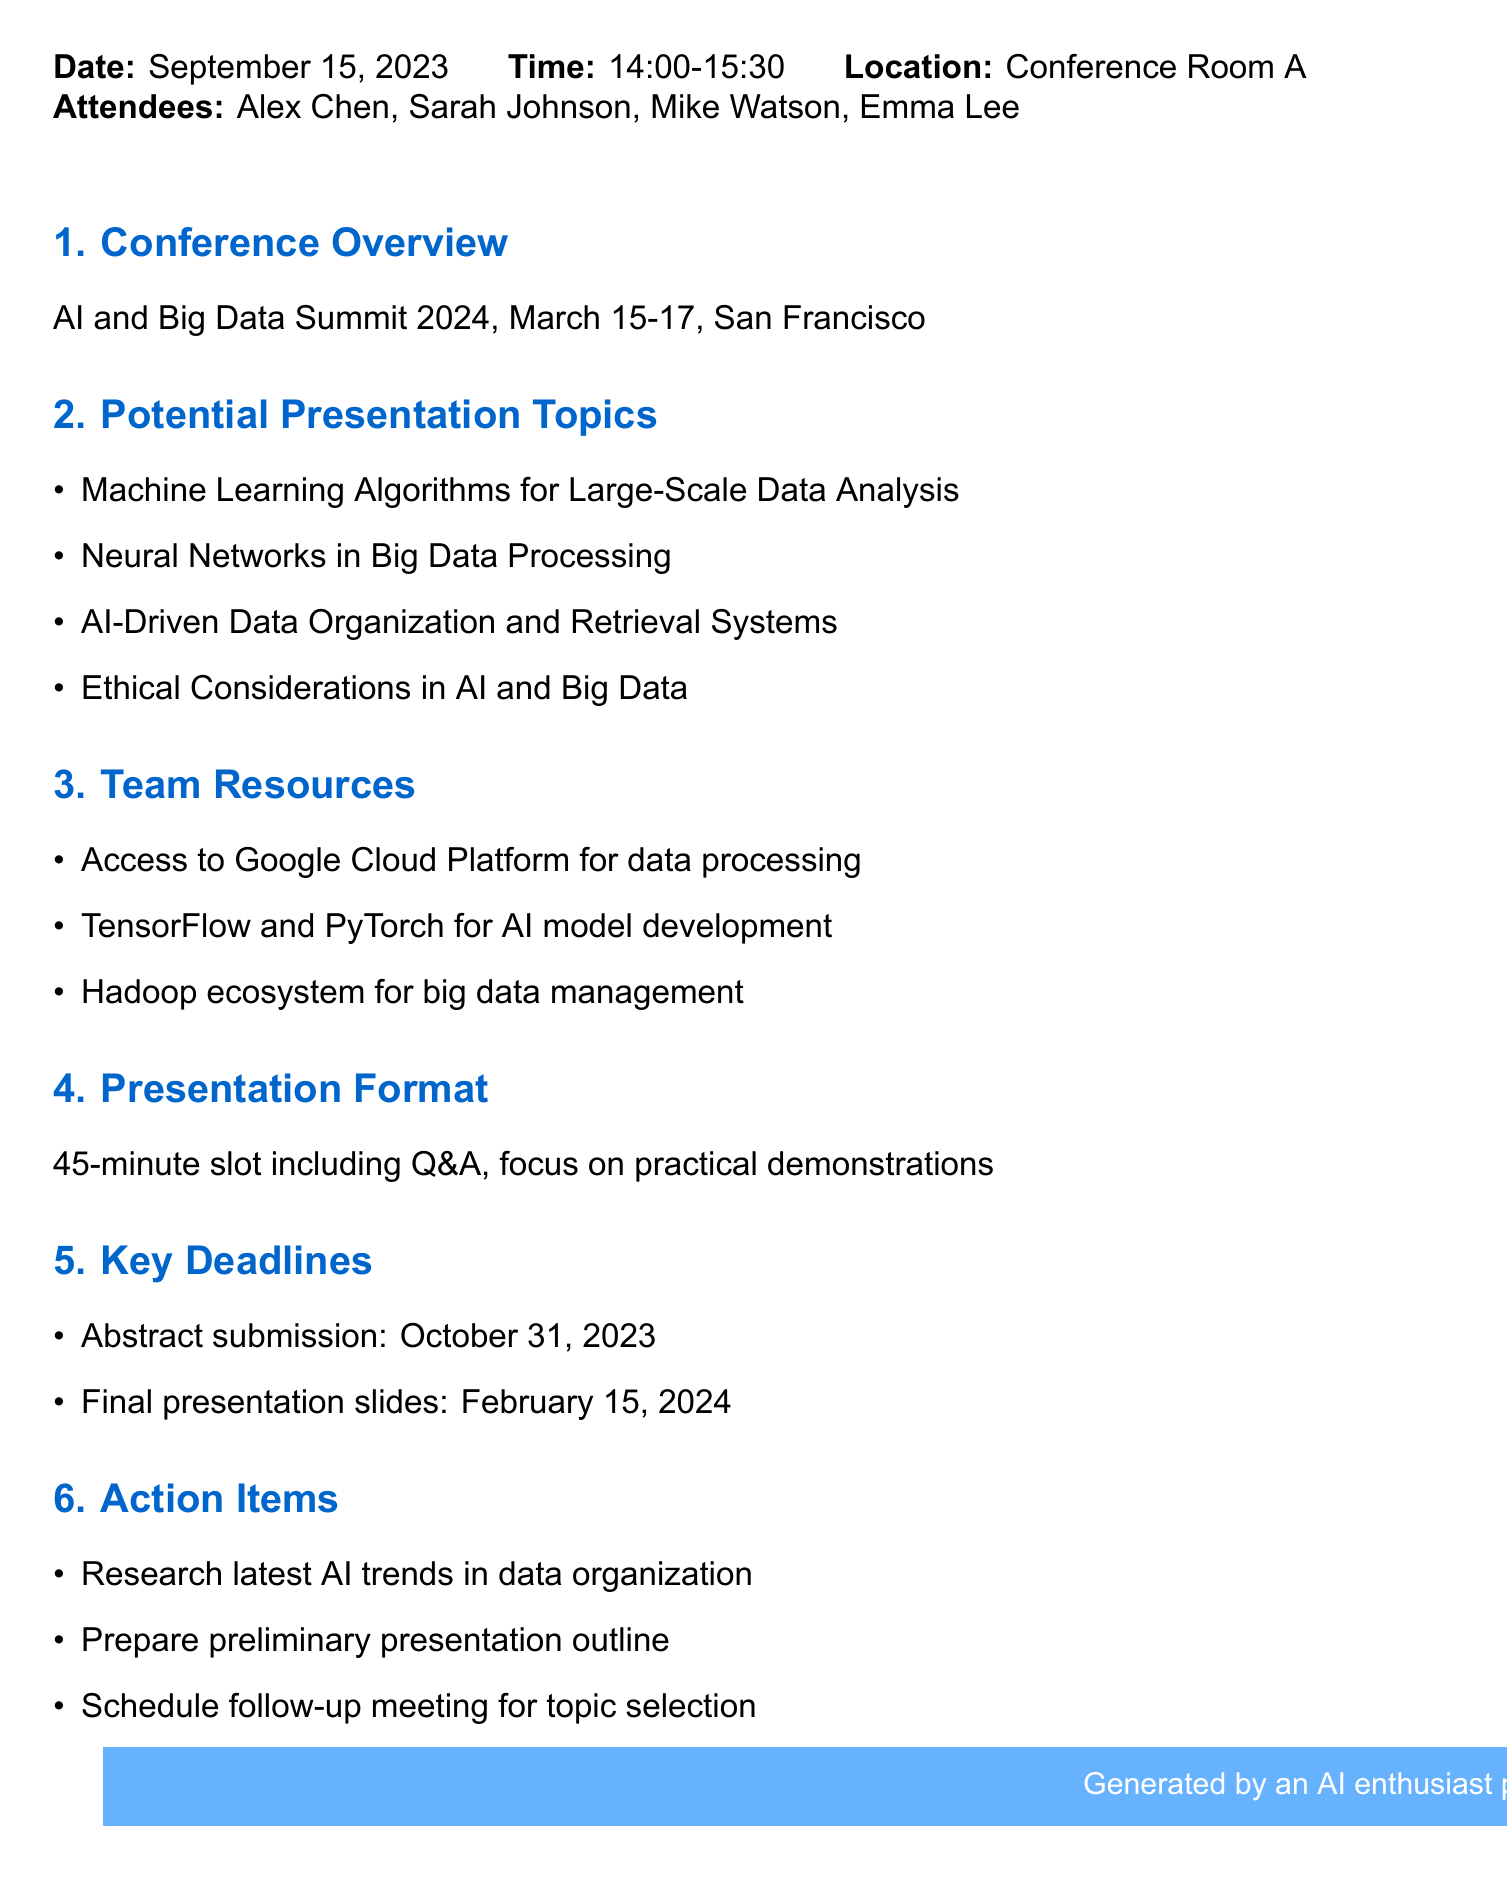What is the date of the meeting? The date of the meeting is mentioned in the document under meeting details.
Answer: September 15, 2023 Who are the attendees? The attendees are listed in the meeting details section of the document.
Answer: Alex Chen, Sarah Johnson, Mike Watson, Emma Lee What are the potential presentation topics? The document lists several potential presentation topics under its agenda items section.
Answer: Machine Learning Algorithms for Large-Scale Data Analysis, Neural Networks in Big Data Processing, AI-Driven Data Organization and Retrieval Systems, Ethical Considerations in AI and Big Data What is the presentation format? The format of the presentation is detailed in the corresponding agenda item.
Answer: 45-minute slot including Q&A, focus on practical demonstrations When is the abstract submission deadline? The document specifies deadlines, including the abstract submission date under key deadlines.
Answer: October 31, 2023 What team resources are mentioned? The resources available for the team are listed in the team resources section of the document.
Answer: Access to Google Cloud Platform for data processing, TensorFlow and PyTorch for AI model development, Hadoop ecosystem for big data management What is the final date for presentation slides? The final date for the presentation slides is provided in the key deadlines of the document.
Answer: February 15, 2024 What is the action item related to AI trends? One of the action items focuses on research related to AI trends, detailed in the action items section.
Answer: Research latest AI trends in data organization 